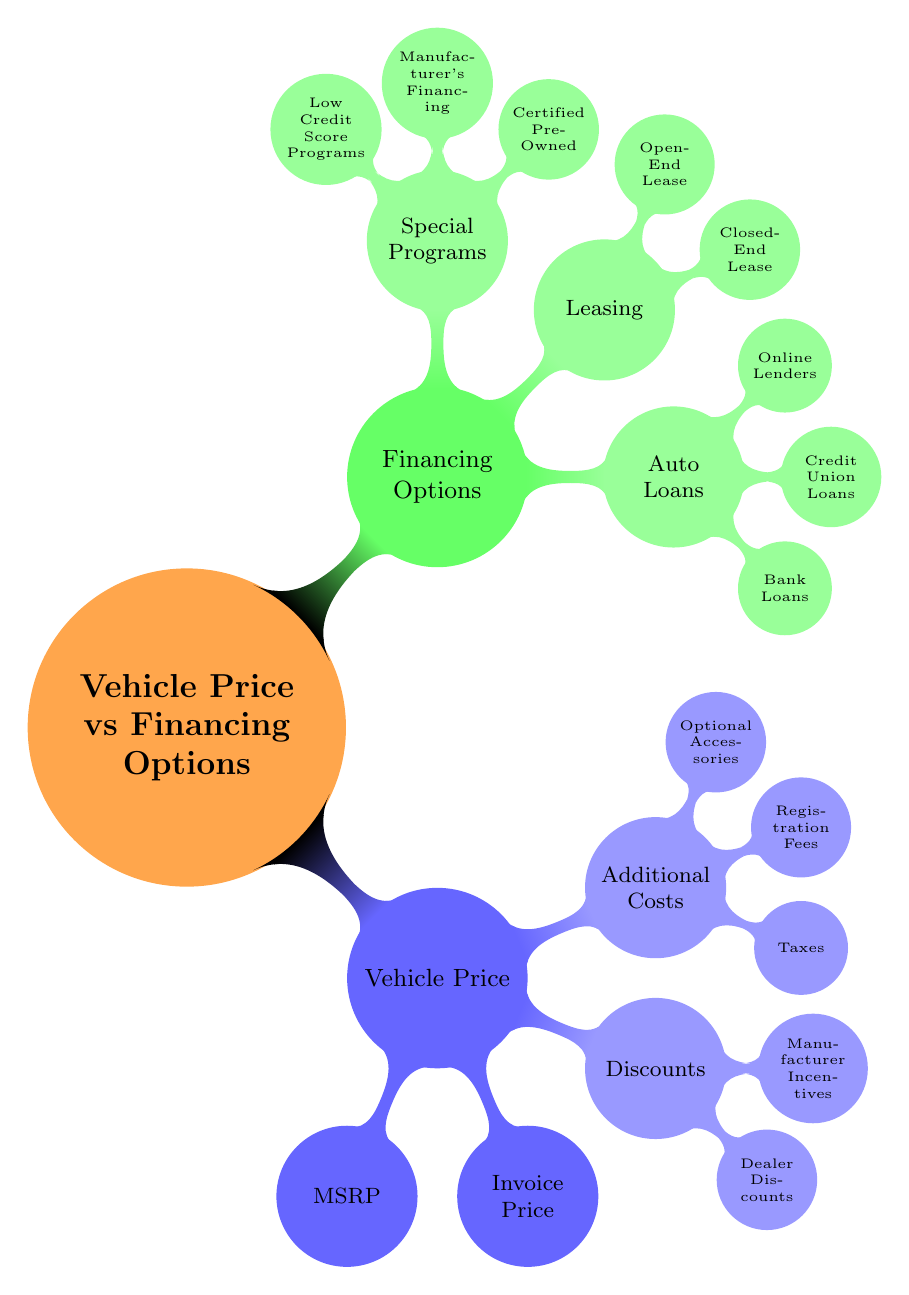What is the highest level in the diagram? The highest level in the diagram is the main concept "Vehicle Price vs Financing Options" which serves as the central node of the mind map, from which all other nodes branch out.
Answer: Vehicle Price vs Financing Options How many financing options are listed? There are three main branches under "Financing Options": Auto Loans, Leasing, and Special Programs. Therefore, the total financing options count is three.
Answer: 3 What are the two types of loans under Auto Loans? Under the "Auto Loans" branch, the two types of loans listed are "Bank Loans" and "Credit Union Loans". These are two separate sub-nodes that provide financing options.
Answer: Bank Loans, Credit Union Loans Which vehicle cost includes local, state, and federal taxes? "Taxes" is mentioned under the "Additional Costs" section of Vehicle Price, and it specifically states that it includes local, state, and federal taxes as part of the vehicle's expenses.
Answer: Taxes What distinguishes Closed-End Leases from Open-End Leases? The distinction is that Closed-End Leases have defined terms and conditions, while Open-End Leases include an option to purchase the vehicle at the end of the lease term, presenting a difference in lease type and flexibility.
Answer: Closed-End Lease, Open-End Lease What financing option is available for buyers with low credit scores? "Low Credit Score Programs" are specifically mentioned under "Special Programs", indicating a targeted financing option for potential buyers who may not qualify for standard financing terms.
Answer: Low Credit Score Programs What type of vehicle price can receive Manufacturer's financing? The "Special Programs" heading lists "Manufacturer's Financing," which suggests it is applicable to vehicles eligible for any special financing arrangements from the vehicle manufacturer.
Answer: Manufacturer's Financing What is represented as Dealer Discounts? Under the "Discounts" section, "Dealer Discounts" are reductions provided by the dealership, indicating a price reduction from the MSRP for customers considering purchasing a vehicle.
Answer: Dealer Discounts 